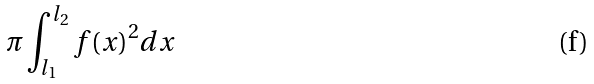<formula> <loc_0><loc_0><loc_500><loc_500>\pi \int _ { l _ { 1 } } ^ { l _ { 2 } } f ( x ) ^ { 2 } d x</formula> 